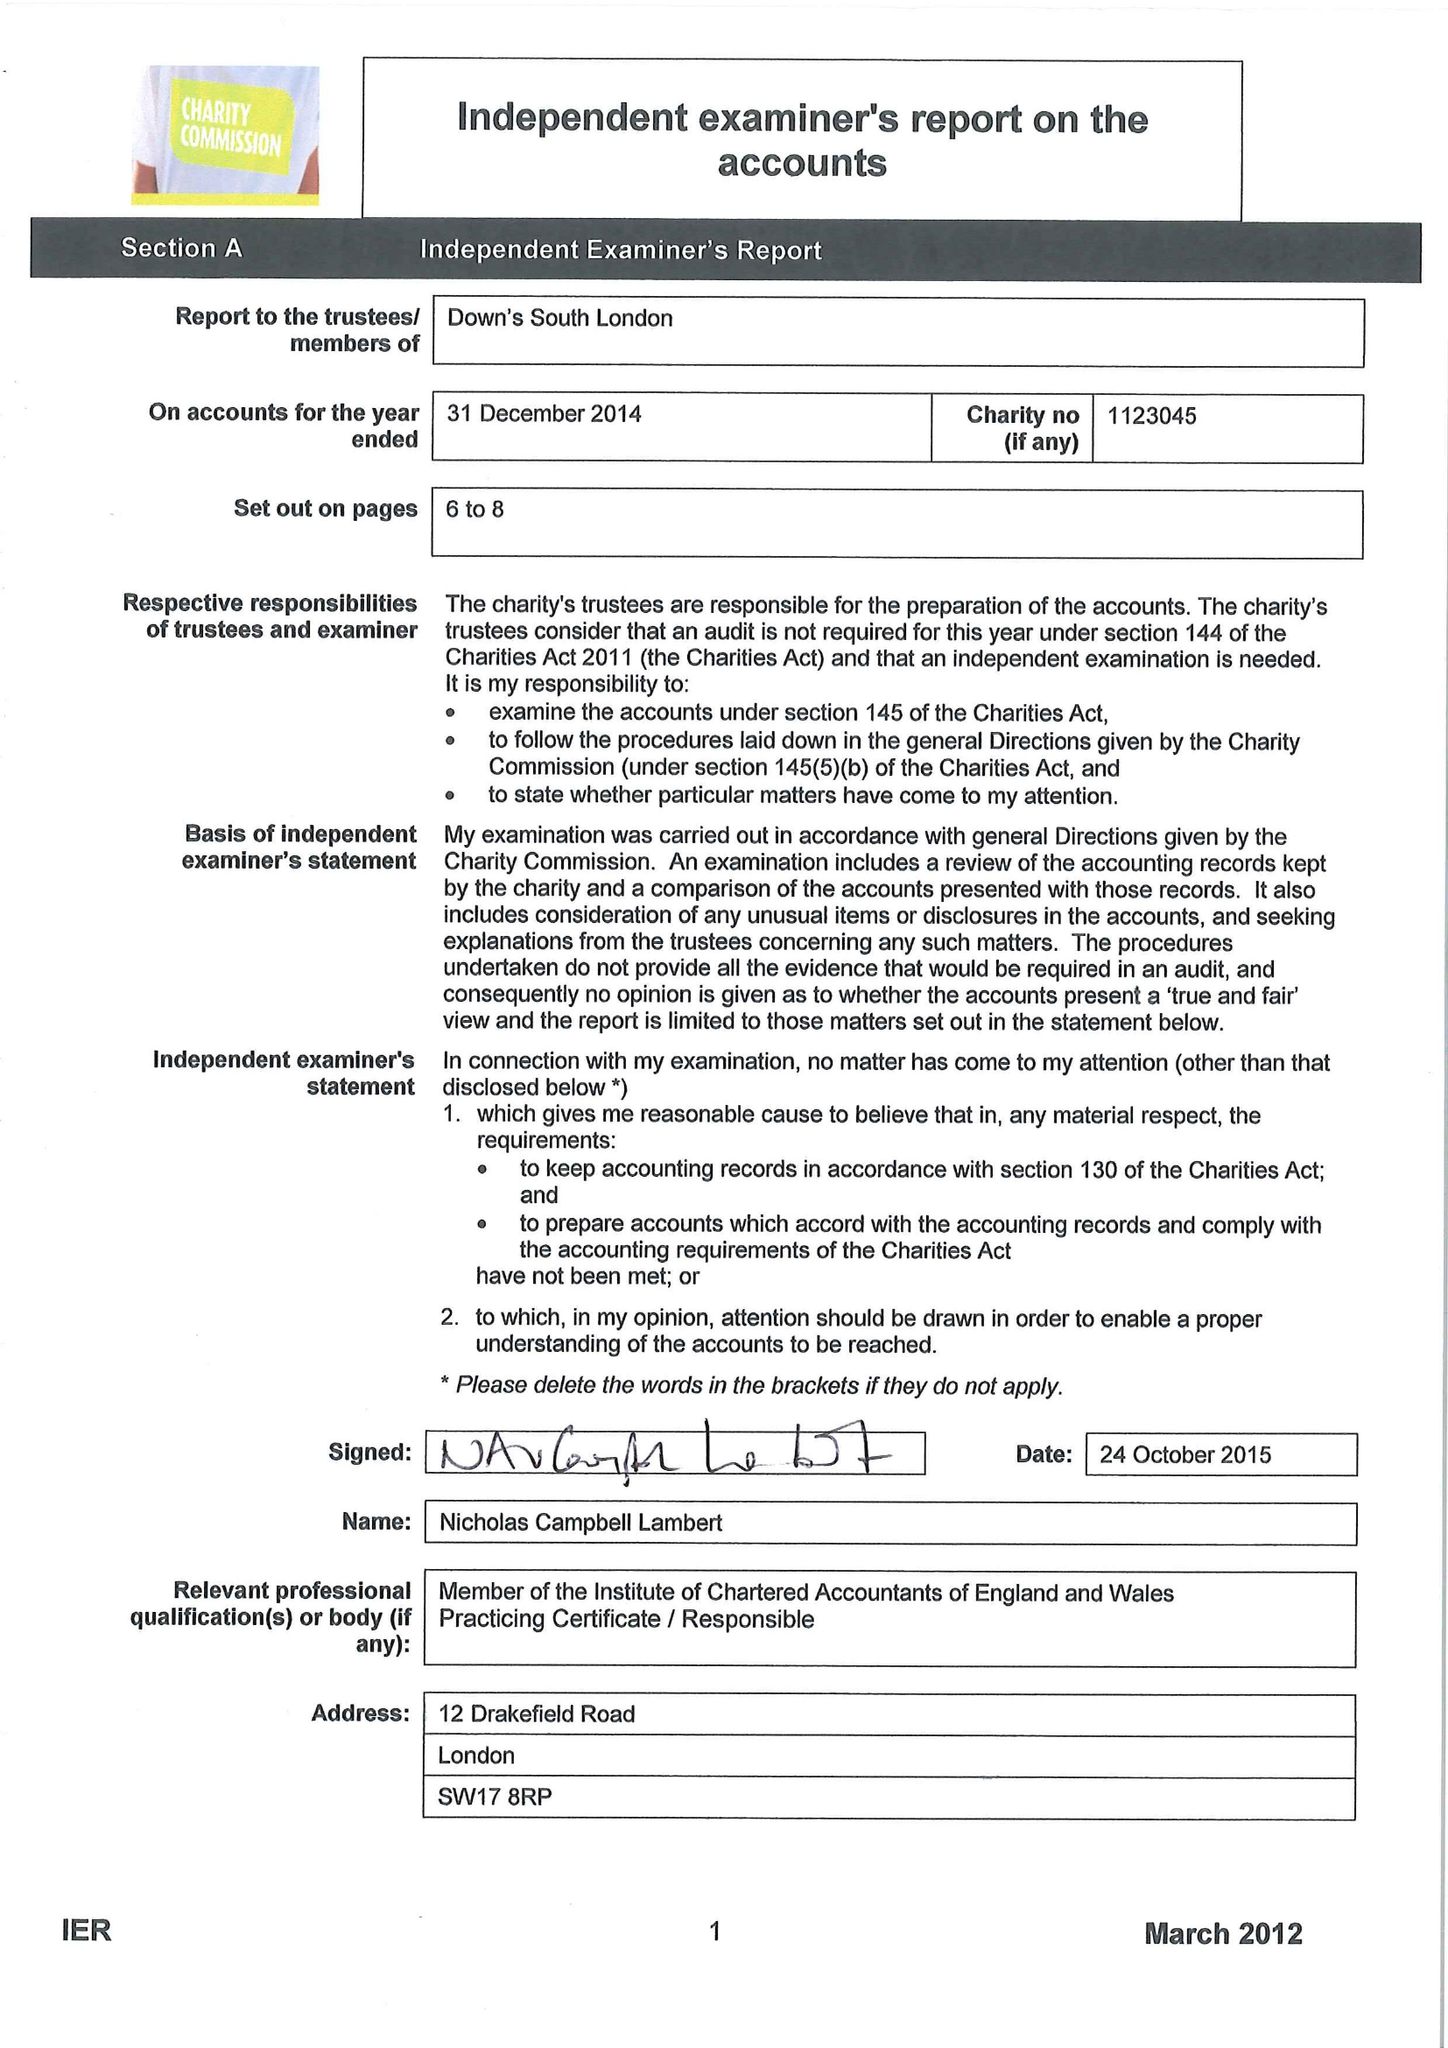What is the value for the address__post_town?
Answer the question using a single word or phrase. LONDON 